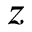Convert formula to latex. <formula><loc_0><loc_0><loc_500><loc_500>z</formula> 